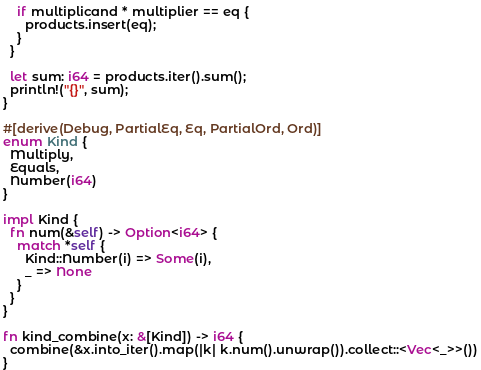<code> <loc_0><loc_0><loc_500><loc_500><_Rust_>
    if multiplicand * multiplier == eq {
      products.insert(eq);
    }
  }

  let sum: i64 = products.iter().sum();
  println!("{}", sum);
}

#[derive(Debug, PartialEq, Eq, PartialOrd, Ord)]
enum Kind {
  Multiply,
  Equals,
  Number(i64)
}

impl Kind {
  fn num(&self) -> Option<i64> {
    match *self {
      Kind::Number(i) => Some(i),
      _ => None
    }
  }
}

fn kind_combine(x: &[Kind]) -> i64 {
  combine(&x.into_iter().map(|k| k.num().unwrap()).collect::<Vec<_>>())
}
</code> 